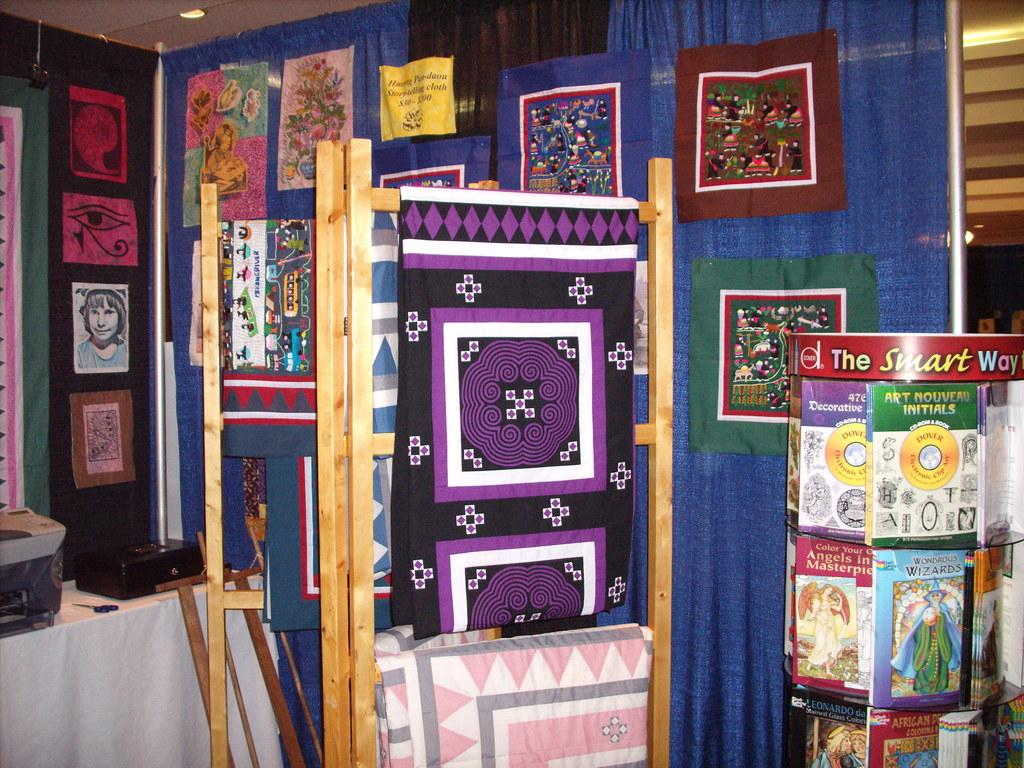What type of items can be seen in the image? There are clothes, photos, and wooden objects in the image. Can you describe the clothes in the image? The clothes in the image are not specified, but they are present. What are the photos of in the image? The content of the photos in the image is not mentioned, but they are visible. What kind of wooden objects can be seen in the image? The wooden objects in the image are not described, but they are present. What riddle is being solved by the grandfather in the image? There is no grandfather or riddle present in the image. How deep is the cave in the image? There is no cave present in the image. 